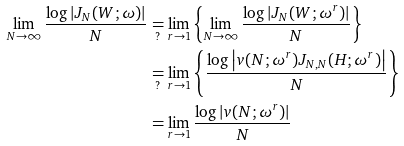Convert formula to latex. <formula><loc_0><loc_0><loc_500><loc_500>\lim _ { N \to \infty } \frac { \log \left | J _ { N } ( W ; \omega ) \right | } { N } & \underset { ? } { = } \lim _ { r \to 1 } \left \{ \lim _ { N \to \infty } \frac { \log \left | J _ { N } ( W ; \omega ^ { r } ) \right | } { N } \right \} \\ & \underset { ? } { = } \lim _ { r \to 1 } \left \{ \frac { \log \left | v ( N ; \omega ^ { r } ) J _ { N , N } ( H ; \omega ^ { r } ) \right | } { N } \right \} \\ & = \lim _ { r \to 1 } \frac { \log \left | v ( N ; \omega ^ { r } ) \right | } { N }</formula> 